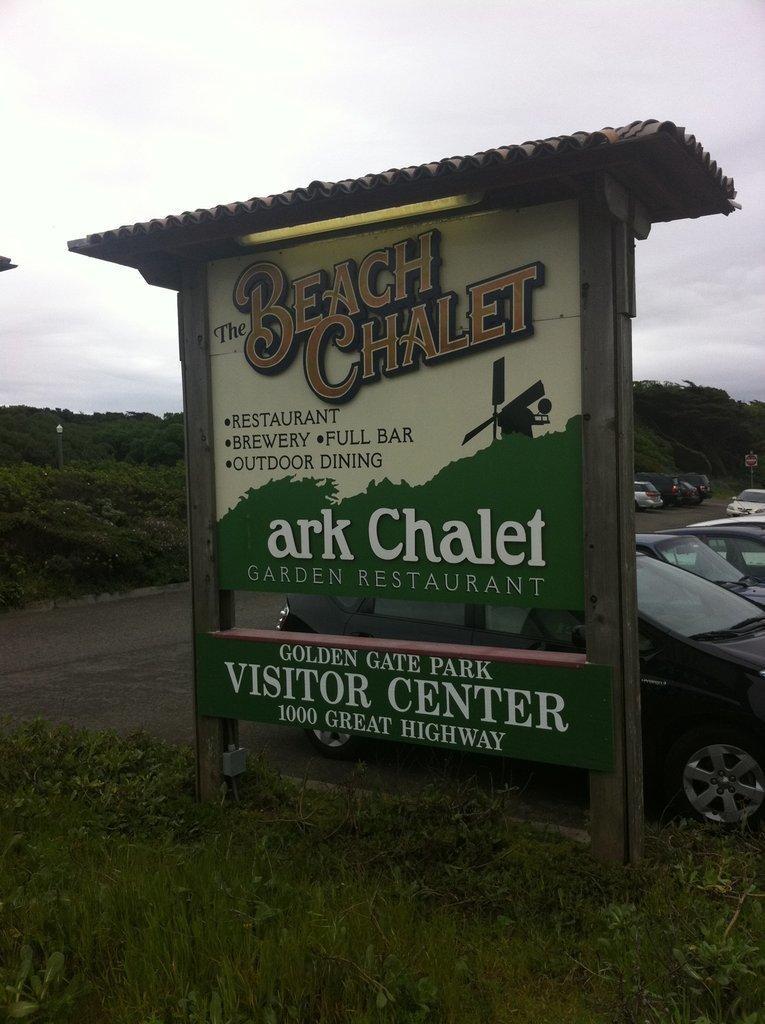Could you give a brief overview of what you see in this image? In this image I can see a board in green and cream color and the board is attached to the pole. Background I can see few vehicles, grass and trees in green color and the sky is in white color. 